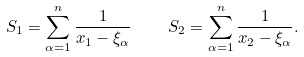Convert formula to latex. <formula><loc_0><loc_0><loc_500><loc_500>S _ { 1 } = \sum _ { \alpha = 1 } ^ { n } \frac { 1 } { x _ { 1 } - \xi _ { \alpha } } \quad S _ { 2 } = \sum _ { \alpha = 1 } ^ { n } \frac { 1 } { x _ { 2 } - \xi _ { \alpha } } .</formula> 